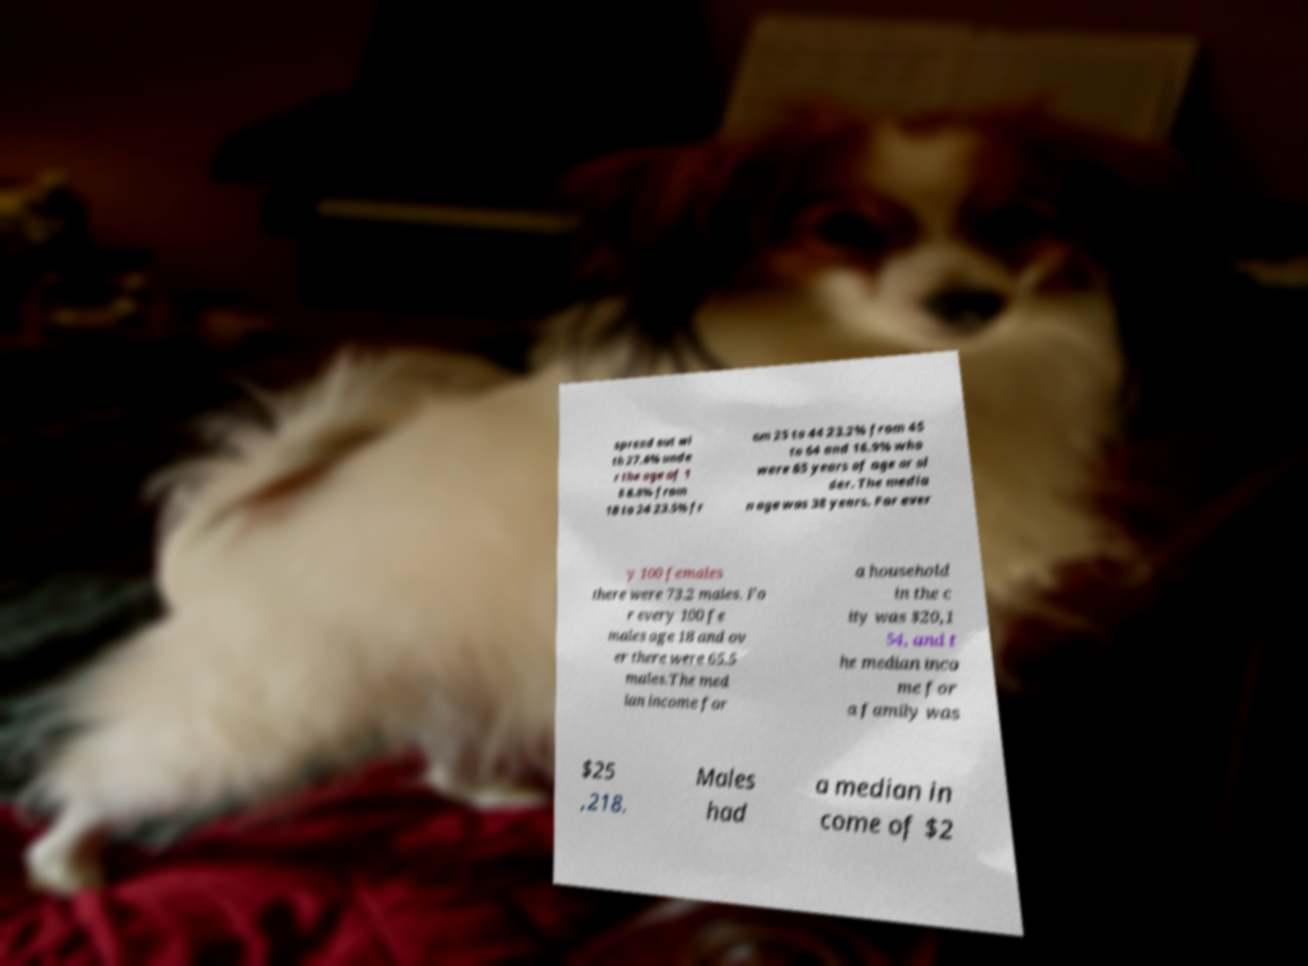Can you read and provide the text displayed in the image?This photo seems to have some interesting text. Can you extract and type it out for me? spread out wi th 27.6% unde r the age of 1 8 8.8% from 18 to 24 23.5% fr om 25 to 44 23.2% from 45 to 64 and 16.9% who were 65 years of age or ol der. The media n age was 38 years. For ever y 100 females there were 73.2 males. Fo r every 100 fe males age 18 and ov er there were 65.5 males.The med ian income for a household in the c ity was $20,1 54, and t he median inco me for a family was $25 ,218. Males had a median in come of $2 